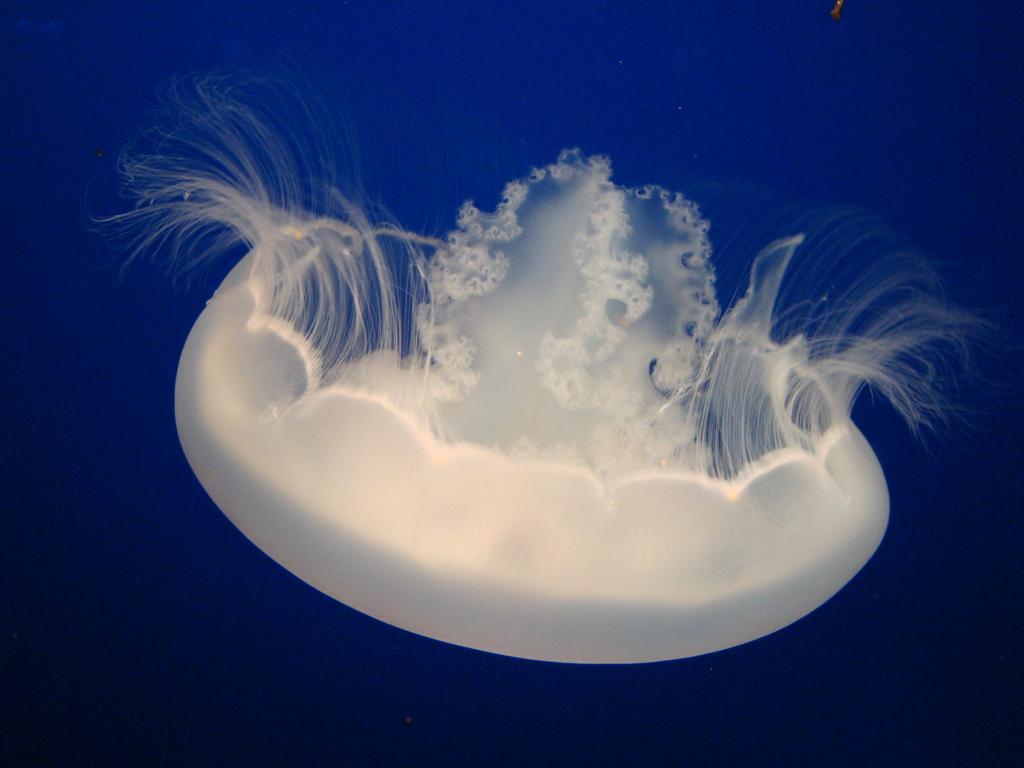How would you summarize this image in a sentence or two? In the middle of this image, there is a white color jellyfish in the water. And the background is blue in color. 